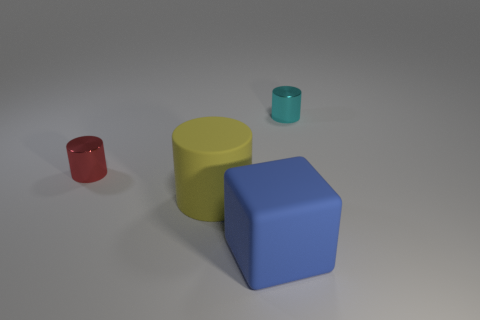Is there any other thing that is the same shape as the big blue thing?
Your answer should be very brief. No. What number of big yellow cylinders are in front of the red cylinder?
Provide a succinct answer. 1. The yellow object that is the same shape as the tiny cyan shiny object is what size?
Keep it short and to the point. Large. What number of cyan things are big rubber objects or big cylinders?
Offer a terse response. 0. How many yellow matte cylinders are in front of the tiny metal object that is on the left side of the large blue matte block?
Ensure brevity in your answer.  1. How many other things are there of the same shape as the tiny cyan metallic thing?
Provide a succinct answer. 2. What number of cubes have the same color as the large rubber cylinder?
Your answer should be very brief. 0. There is another tiny cylinder that is the same material as the red cylinder; what color is it?
Make the answer very short. Cyan. Is there a rubber thing of the same size as the yellow cylinder?
Give a very brief answer. Yes. Is the number of large rubber things behind the rubber block greater than the number of small red shiny cylinders in front of the small red shiny cylinder?
Provide a succinct answer. Yes. 